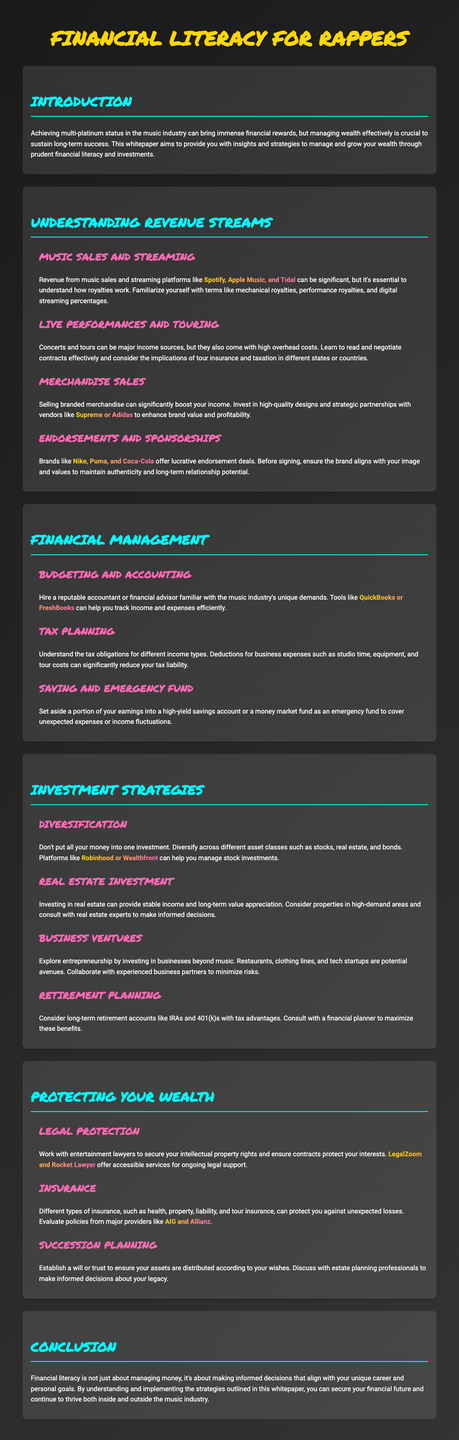What is the main goal of the whitepaper? The whitepaper aims to provide insights and strategies to manage and grow wealth through financial literacy and investments.
Answer: Managing wealth What are the platforms mentioned for music sales and streaming? The document lists Spotify, Apple Music, and Tidal as significant platforms for music sales and streaming.
Answer: Spotify, Apple Music, Tidal Which brands are mentioned regarding merchandise sales? The highlighted brands in the document for merchandise sales are Supreme and Adidas.
Answer: Supreme, Adidas What is one tool suggested for budgeting? The document recommends using QuickBooks or FreshBooks for tracking income and expenses efficiently.
Answer: QuickBooks, FreshBooks Name two types of insurance mentioned for protecting wealth. The document lists health insurance and tour insurance as types of insurance for protection.
Answer: Health, tour What should be established to ensure asset distribution according to wishes? A will or trust should be established to ensure assets are distributed according to your wishes.
Answer: Will, trust What is suggested for long-term retirement planning? The document suggests considering long-term retirement accounts like IRAs and 401(k)s with tax advantages.
Answer: IRAs, 401(k)s Why is it important to understand tax obligations? Understanding tax obligations is crucial because deductions can significantly reduce tax liability.
Answer: Reduce tax liability What investment strategy is emphasized in the document? Diversification is emphasized as an important investment strategy.
Answer: Diversification 